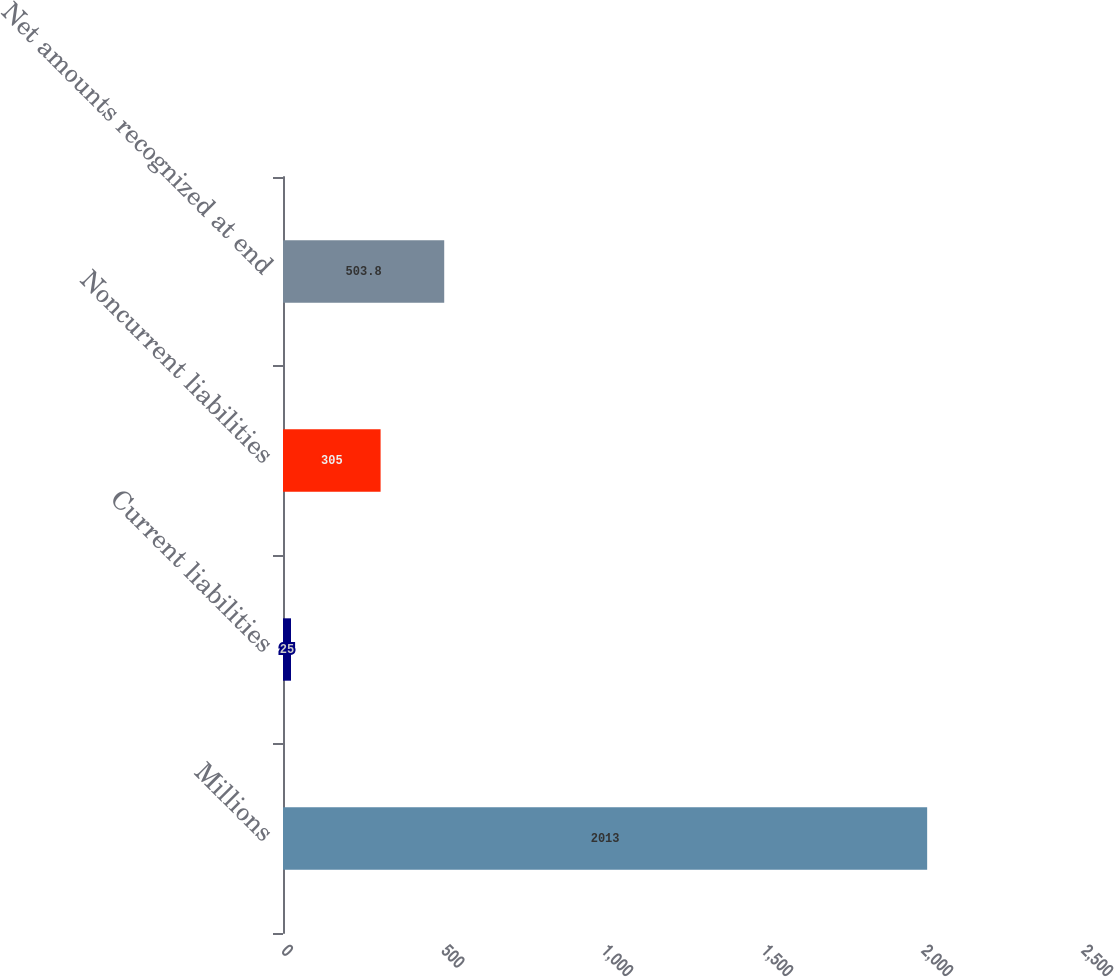Convert chart. <chart><loc_0><loc_0><loc_500><loc_500><bar_chart><fcel>Millions<fcel>Current liabilities<fcel>Noncurrent liabilities<fcel>Net amounts recognized at end<nl><fcel>2013<fcel>25<fcel>305<fcel>503.8<nl></chart> 